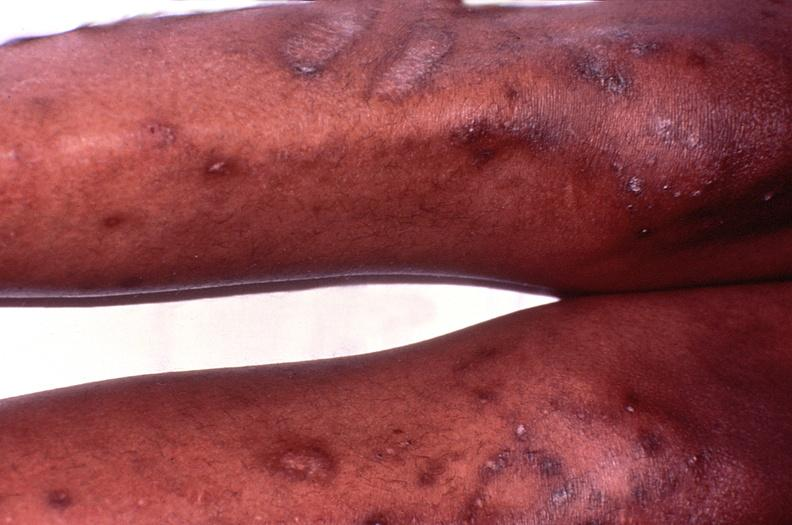does typical tuberculous exudate show cryptococcal dematitis?
Answer the question using a single word or phrase. No 